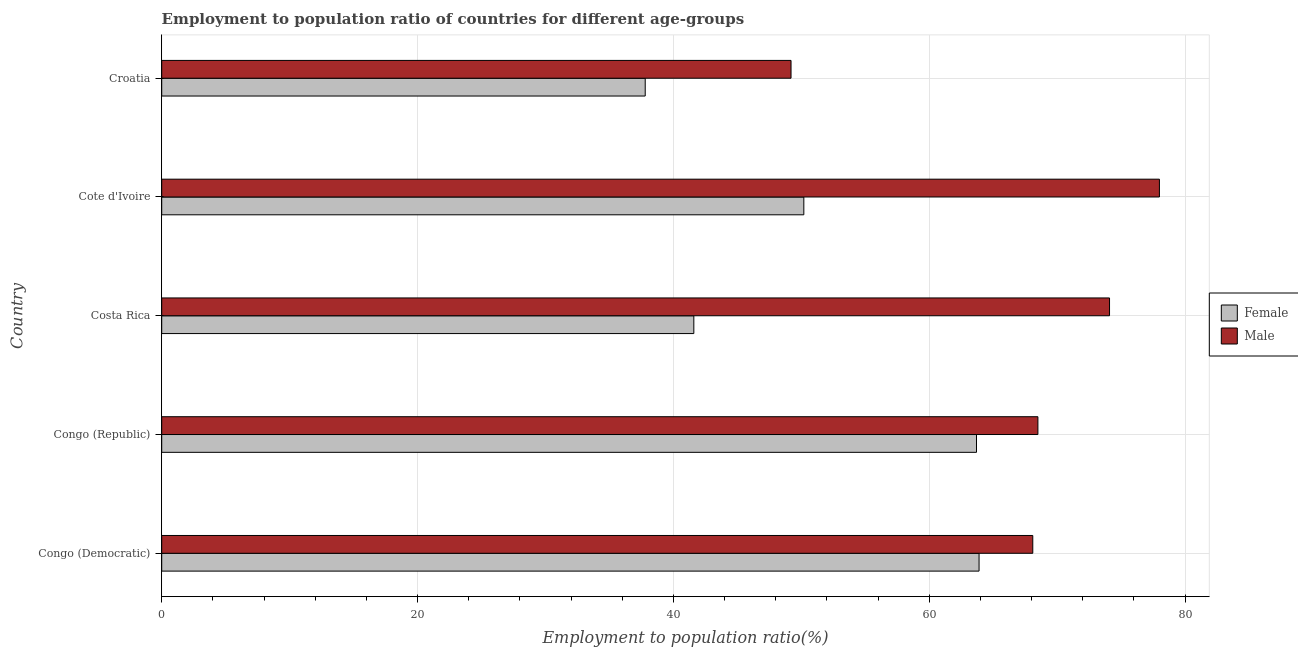How many groups of bars are there?
Your answer should be very brief. 5. Are the number of bars per tick equal to the number of legend labels?
Offer a terse response. Yes. Are the number of bars on each tick of the Y-axis equal?
Your answer should be compact. Yes. How many bars are there on the 2nd tick from the top?
Make the answer very short. 2. How many bars are there on the 4th tick from the bottom?
Your response must be concise. 2. What is the label of the 1st group of bars from the top?
Provide a succinct answer. Croatia. In how many cases, is the number of bars for a given country not equal to the number of legend labels?
Make the answer very short. 0. What is the employment to population ratio(male) in Costa Rica?
Make the answer very short. 74.1. Across all countries, what is the maximum employment to population ratio(female)?
Your response must be concise. 63.9. Across all countries, what is the minimum employment to population ratio(female)?
Your response must be concise. 37.8. In which country was the employment to population ratio(female) maximum?
Give a very brief answer. Congo (Democratic). In which country was the employment to population ratio(female) minimum?
Ensure brevity in your answer.  Croatia. What is the total employment to population ratio(male) in the graph?
Make the answer very short. 337.9. What is the difference between the employment to population ratio(female) in Congo (Democratic) and that in Congo (Republic)?
Give a very brief answer. 0.2. What is the difference between the employment to population ratio(female) in Croatia and the employment to population ratio(male) in Cote d'Ivoire?
Keep it short and to the point. -40.2. What is the average employment to population ratio(female) per country?
Provide a succinct answer. 51.44. What is the difference between the employment to population ratio(male) and employment to population ratio(female) in Congo (Democratic)?
Your answer should be very brief. 4.2. In how many countries, is the employment to population ratio(female) greater than 4 %?
Your answer should be very brief. 5. What is the ratio of the employment to population ratio(female) in Cote d'Ivoire to that in Croatia?
Provide a short and direct response. 1.33. What is the difference between the highest and the lowest employment to population ratio(male)?
Give a very brief answer. 28.8. In how many countries, is the employment to population ratio(female) greater than the average employment to population ratio(female) taken over all countries?
Provide a short and direct response. 2. What does the 1st bar from the bottom in Congo (Republic) represents?
Keep it short and to the point. Female. How many bars are there?
Offer a very short reply. 10. How many countries are there in the graph?
Provide a short and direct response. 5. Are the values on the major ticks of X-axis written in scientific E-notation?
Give a very brief answer. No. Does the graph contain any zero values?
Offer a very short reply. No. Does the graph contain grids?
Provide a short and direct response. Yes. Where does the legend appear in the graph?
Ensure brevity in your answer.  Center right. How are the legend labels stacked?
Your response must be concise. Vertical. What is the title of the graph?
Give a very brief answer. Employment to population ratio of countries for different age-groups. Does "Public credit registry" appear as one of the legend labels in the graph?
Your response must be concise. No. What is the label or title of the X-axis?
Offer a terse response. Employment to population ratio(%). What is the label or title of the Y-axis?
Provide a short and direct response. Country. What is the Employment to population ratio(%) in Female in Congo (Democratic)?
Provide a succinct answer. 63.9. What is the Employment to population ratio(%) in Male in Congo (Democratic)?
Your answer should be very brief. 68.1. What is the Employment to population ratio(%) in Female in Congo (Republic)?
Keep it short and to the point. 63.7. What is the Employment to population ratio(%) of Male in Congo (Republic)?
Make the answer very short. 68.5. What is the Employment to population ratio(%) in Female in Costa Rica?
Ensure brevity in your answer.  41.6. What is the Employment to population ratio(%) of Male in Costa Rica?
Provide a succinct answer. 74.1. What is the Employment to population ratio(%) in Female in Cote d'Ivoire?
Keep it short and to the point. 50.2. What is the Employment to population ratio(%) in Male in Cote d'Ivoire?
Give a very brief answer. 78. What is the Employment to population ratio(%) of Female in Croatia?
Keep it short and to the point. 37.8. What is the Employment to population ratio(%) in Male in Croatia?
Give a very brief answer. 49.2. Across all countries, what is the maximum Employment to population ratio(%) in Female?
Provide a short and direct response. 63.9. Across all countries, what is the maximum Employment to population ratio(%) in Male?
Make the answer very short. 78. Across all countries, what is the minimum Employment to population ratio(%) in Female?
Your answer should be compact. 37.8. Across all countries, what is the minimum Employment to population ratio(%) in Male?
Ensure brevity in your answer.  49.2. What is the total Employment to population ratio(%) in Female in the graph?
Your response must be concise. 257.2. What is the total Employment to population ratio(%) in Male in the graph?
Ensure brevity in your answer.  337.9. What is the difference between the Employment to population ratio(%) in Female in Congo (Democratic) and that in Costa Rica?
Your answer should be compact. 22.3. What is the difference between the Employment to population ratio(%) of Male in Congo (Democratic) and that in Costa Rica?
Your answer should be very brief. -6. What is the difference between the Employment to population ratio(%) in Male in Congo (Democratic) and that in Cote d'Ivoire?
Provide a succinct answer. -9.9. What is the difference between the Employment to population ratio(%) in Female in Congo (Democratic) and that in Croatia?
Provide a succinct answer. 26.1. What is the difference between the Employment to population ratio(%) in Male in Congo (Democratic) and that in Croatia?
Your answer should be very brief. 18.9. What is the difference between the Employment to population ratio(%) of Female in Congo (Republic) and that in Costa Rica?
Give a very brief answer. 22.1. What is the difference between the Employment to population ratio(%) in Male in Congo (Republic) and that in Cote d'Ivoire?
Provide a succinct answer. -9.5. What is the difference between the Employment to population ratio(%) in Female in Congo (Republic) and that in Croatia?
Ensure brevity in your answer.  25.9. What is the difference between the Employment to population ratio(%) in Male in Congo (Republic) and that in Croatia?
Make the answer very short. 19.3. What is the difference between the Employment to population ratio(%) of Female in Costa Rica and that in Cote d'Ivoire?
Offer a very short reply. -8.6. What is the difference between the Employment to population ratio(%) in Male in Costa Rica and that in Croatia?
Your answer should be very brief. 24.9. What is the difference between the Employment to population ratio(%) of Male in Cote d'Ivoire and that in Croatia?
Your answer should be compact. 28.8. What is the difference between the Employment to population ratio(%) of Female in Congo (Democratic) and the Employment to population ratio(%) of Male in Congo (Republic)?
Your answer should be very brief. -4.6. What is the difference between the Employment to population ratio(%) of Female in Congo (Democratic) and the Employment to population ratio(%) of Male in Cote d'Ivoire?
Ensure brevity in your answer.  -14.1. What is the difference between the Employment to population ratio(%) in Female in Congo (Republic) and the Employment to population ratio(%) in Male in Cote d'Ivoire?
Ensure brevity in your answer.  -14.3. What is the difference between the Employment to population ratio(%) in Female in Congo (Republic) and the Employment to population ratio(%) in Male in Croatia?
Your response must be concise. 14.5. What is the difference between the Employment to population ratio(%) in Female in Costa Rica and the Employment to population ratio(%) in Male in Cote d'Ivoire?
Offer a terse response. -36.4. What is the difference between the Employment to population ratio(%) of Female in Costa Rica and the Employment to population ratio(%) of Male in Croatia?
Provide a succinct answer. -7.6. What is the difference between the Employment to population ratio(%) in Female in Cote d'Ivoire and the Employment to population ratio(%) in Male in Croatia?
Provide a short and direct response. 1. What is the average Employment to population ratio(%) of Female per country?
Offer a terse response. 51.44. What is the average Employment to population ratio(%) of Male per country?
Offer a terse response. 67.58. What is the difference between the Employment to population ratio(%) of Female and Employment to population ratio(%) of Male in Congo (Democratic)?
Your answer should be compact. -4.2. What is the difference between the Employment to population ratio(%) of Female and Employment to population ratio(%) of Male in Costa Rica?
Keep it short and to the point. -32.5. What is the difference between the Employment to population ratio(%) in Female and Employment to population ratio(%) in Male in Cote d'Ivoire?
Offer a very short reply. -27.8. What is the ratio of the Employment to population ratio(%) of Female in Congo (Democratic) to that in Congo (Republic)?
Your response must be concise. 1. What is the ratio of the Employment to population ratio(%) of Male in Congo (Democratic) to that in Congo (Republic)?
Offer a very short reply. 0.99. What is the ratio of the Employment to population ratio(%) in Female in Congo (Democratic) to that in Costa Rica?
Offer a terse response. 1.54. What is the ratio of the Employment to population ratio(%) in Male in Congo (Democratic) to that in Costa Rica?
Provide a succinct answer. 0.92. What is the ratio of the Employment to population ratio(%) of Female in Congo (Democratic) to that in Cote d'Ivoire?
Provide a short and direct response. 1.27. What is the ratio of the Employment to population ratio(%) in Male in Congo (Democratic) to that in Cote d'Ivoire?
Provide a short and direct response. 0.87. What is the ratio of the Employment to population ratio(%) in Female in Congo (Democratic) to that in Croatia?
Provide a succinct answer. 1.69. What is the ratio of the Employment to population ratio(%) of Male in Congo (Democratic) to that in Croatia?
Provide a succinct answer. 1.38. What is the ratio of the Employment to population ratio(%) of Female in Congo (Republic) to that in Costa Rica?
Ensure brevity in your answer.  1.53. What is the ratio of the Employment to population ratio(%) in Male in Congo (Republic) to that in Costa Rica?
Ensure brevity in your answer.  0.92. What is the ratio of the Employment to population ratio(%) of Female in Congo (Republic) to that in Cote d'Ivoire?
Provide a succinct answer. 1.27. What is the ratio of the Employment to population ratio(%) in Male in Congo (Republic) to that in Cote d'Ivoire?
Your response must be concise. 0.88. What is the ratio of the Employment to population ratio(%) in Female in Congo (Republic) to that in Croatia?
Keep it short and to the point. 1.69. What is the ratio of the Employment to population ratio(%) of Male in Congo (Republic) to that in Croatia?
Offer a very short reply. 1.39. What is the ratio of the Employment to population ratio(%) in Female in Costa Rica to that in Cote d'Ivoire?
Provide a short and direct response. 0.83. What is the ratio of the Employment to population ratio(%) of Female in Costa Rica to that in Croatia?
Offer a terse response. 1.1. What is the ratio of the Employment to population ratio(%) in Male in Costa Rica to that in Croatia?
Provide a short and direct response. 1.51. What is the ratio of the Employment to population ratio(%) of Female in Cote d'Ivoire to that in Croatia?
Make the answer very short. 1.33. What is the ratio of the Employment to population ratio(%) of Male in Cote d'Ivoire to that in Croatia?
Your response must be concise. 1.59. What is the difference between the highest and the second highest Employment to population ratio(%) of Male?
Keep it short and to the point. 3.9. What is the difference between the highest and the lowest Employment to population ratio(%) of Female?
Your answer should be compact. 26.1. What is the difference between the highest and the lowest Employment to population ratio(%) of Male?
Ensure brevity in your answer.  28.8. 